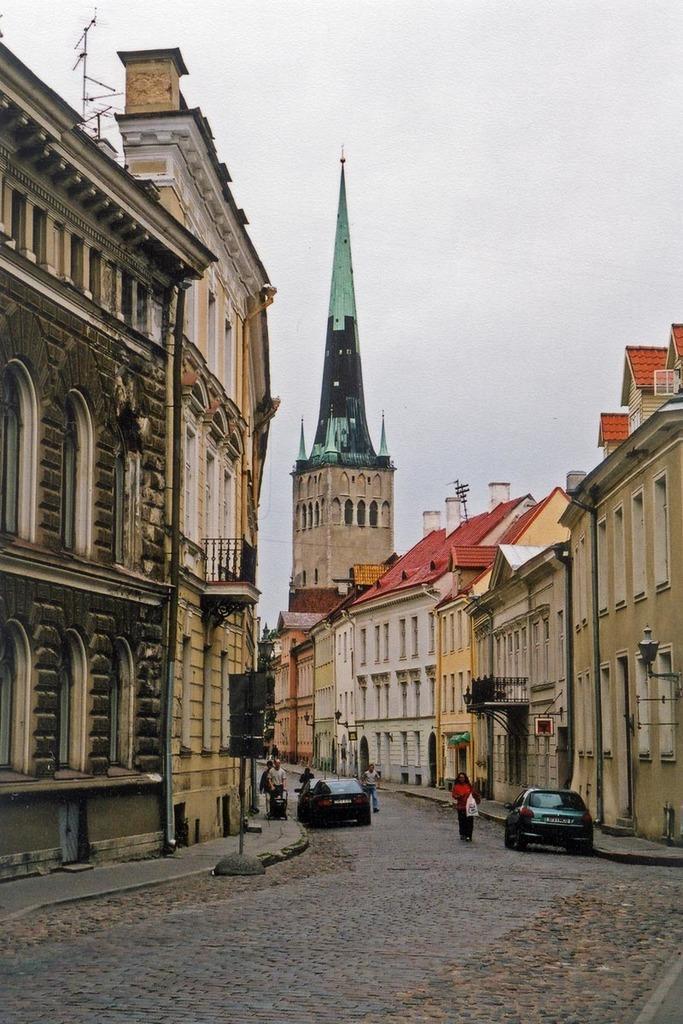Could you give a brief overview of what you see in this image? In this image there are two cars on the road. Few persons are walking on the road. A person wearing red top is holding a bag. Few persons are walking on the pavement. A person is holding a baby trolley. Beside pavement there is a pole having few boards attached to it. In background there are few buildings. Top of image there is sky. 